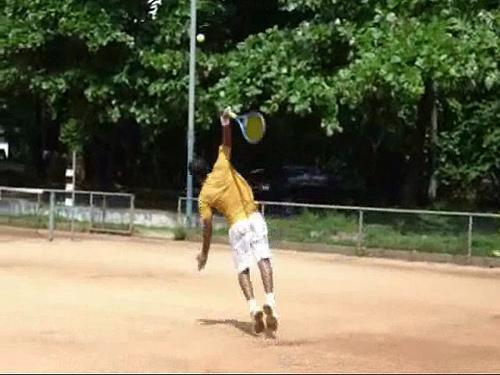The player is using all his energy when preparing to do what with the ball?

Choices:
A) bunce it
B) throw it
C) roll it
D) serve it serve it 